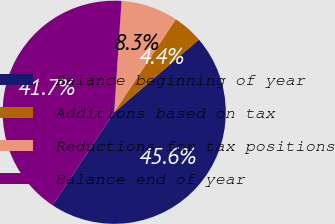Convert chart to OTSL. <chart><loc_0><loc_0><loc_500><loc_500><pie_chart><fcel>Balance beginning of year<fcel>Additions based on tax<fcel>Reductions for tax positions<fcel>Balance end of year<nl><fcel>45.61%<fcel>4.39%<fcel>8.27%<fcel>41.73%<nl></chart> 